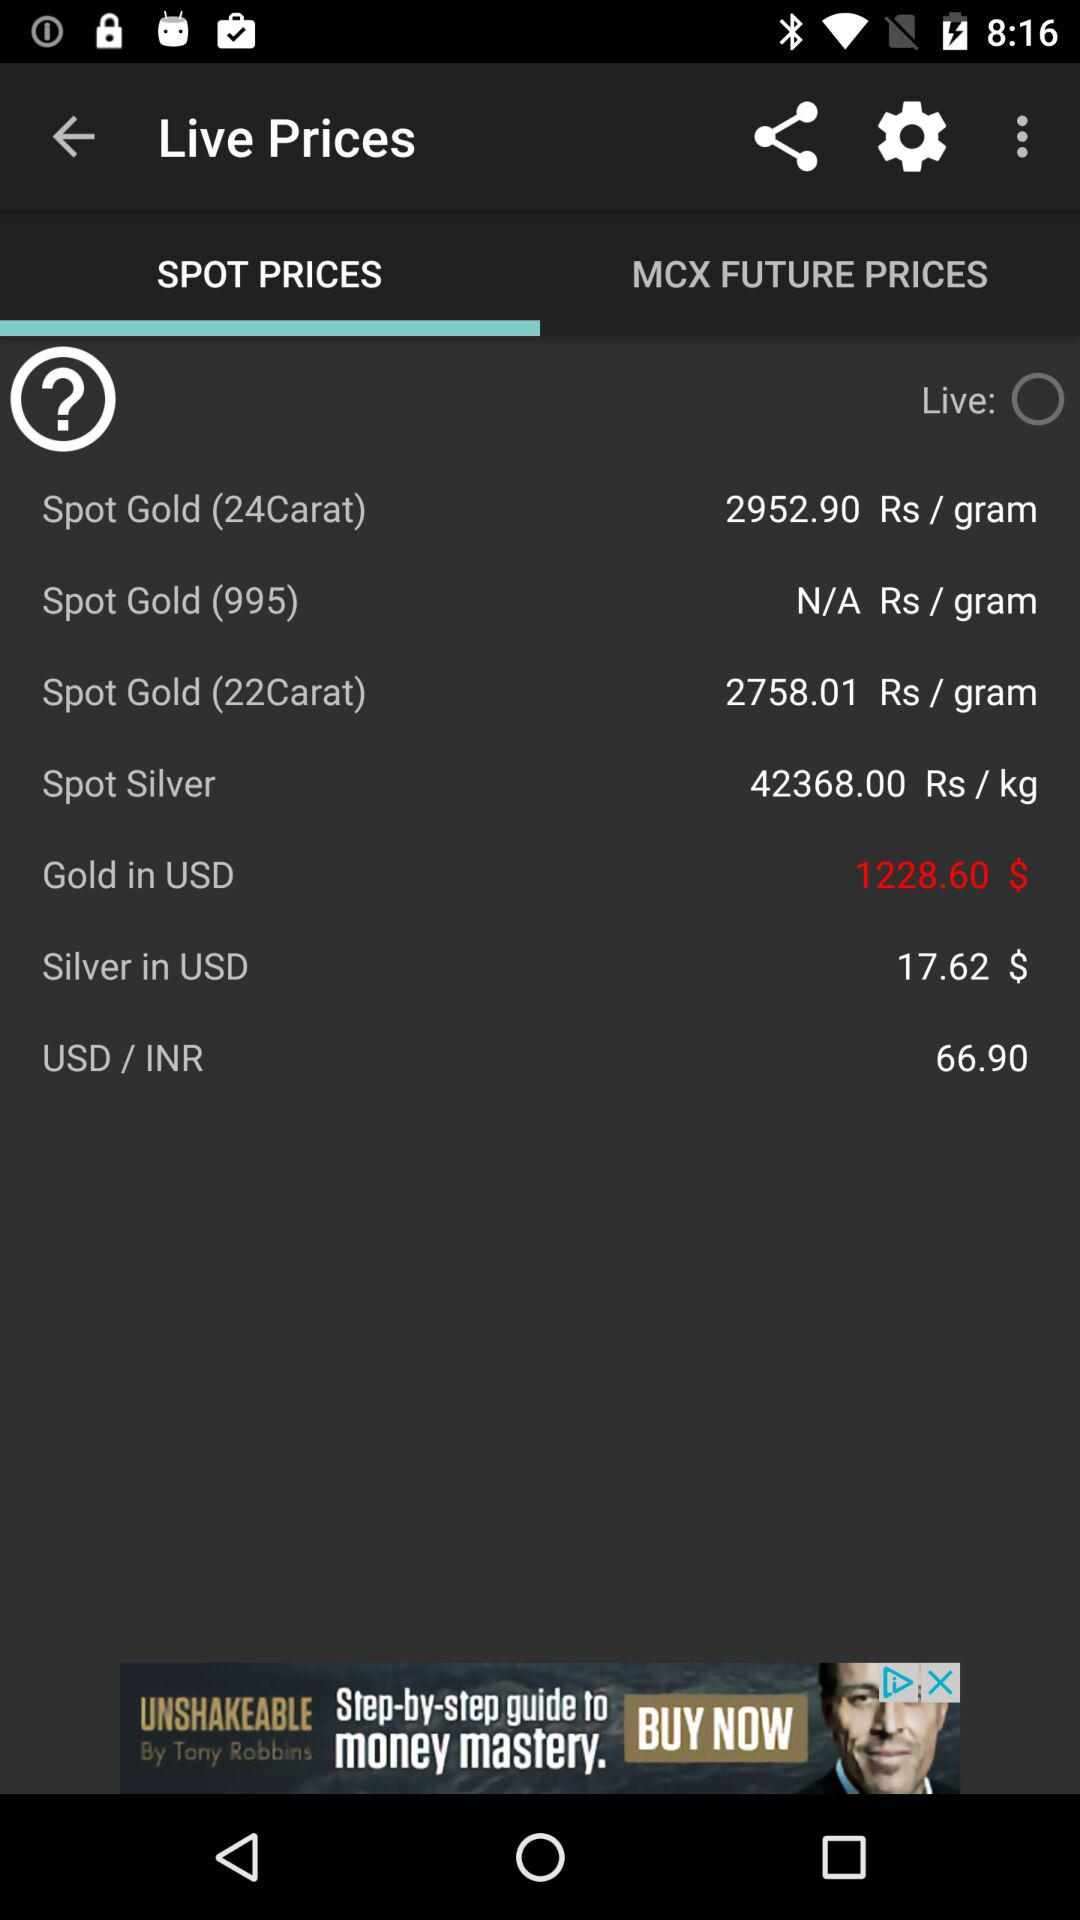What is the rate of "Spot Gold (22Carat)"? The rate of "Spot Gold (22Carat)" is 2758.01 rupees per gram. 